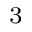<formula> <loc_0><loc_0><loc_500><loc_500>^ { 3 }</formula> 